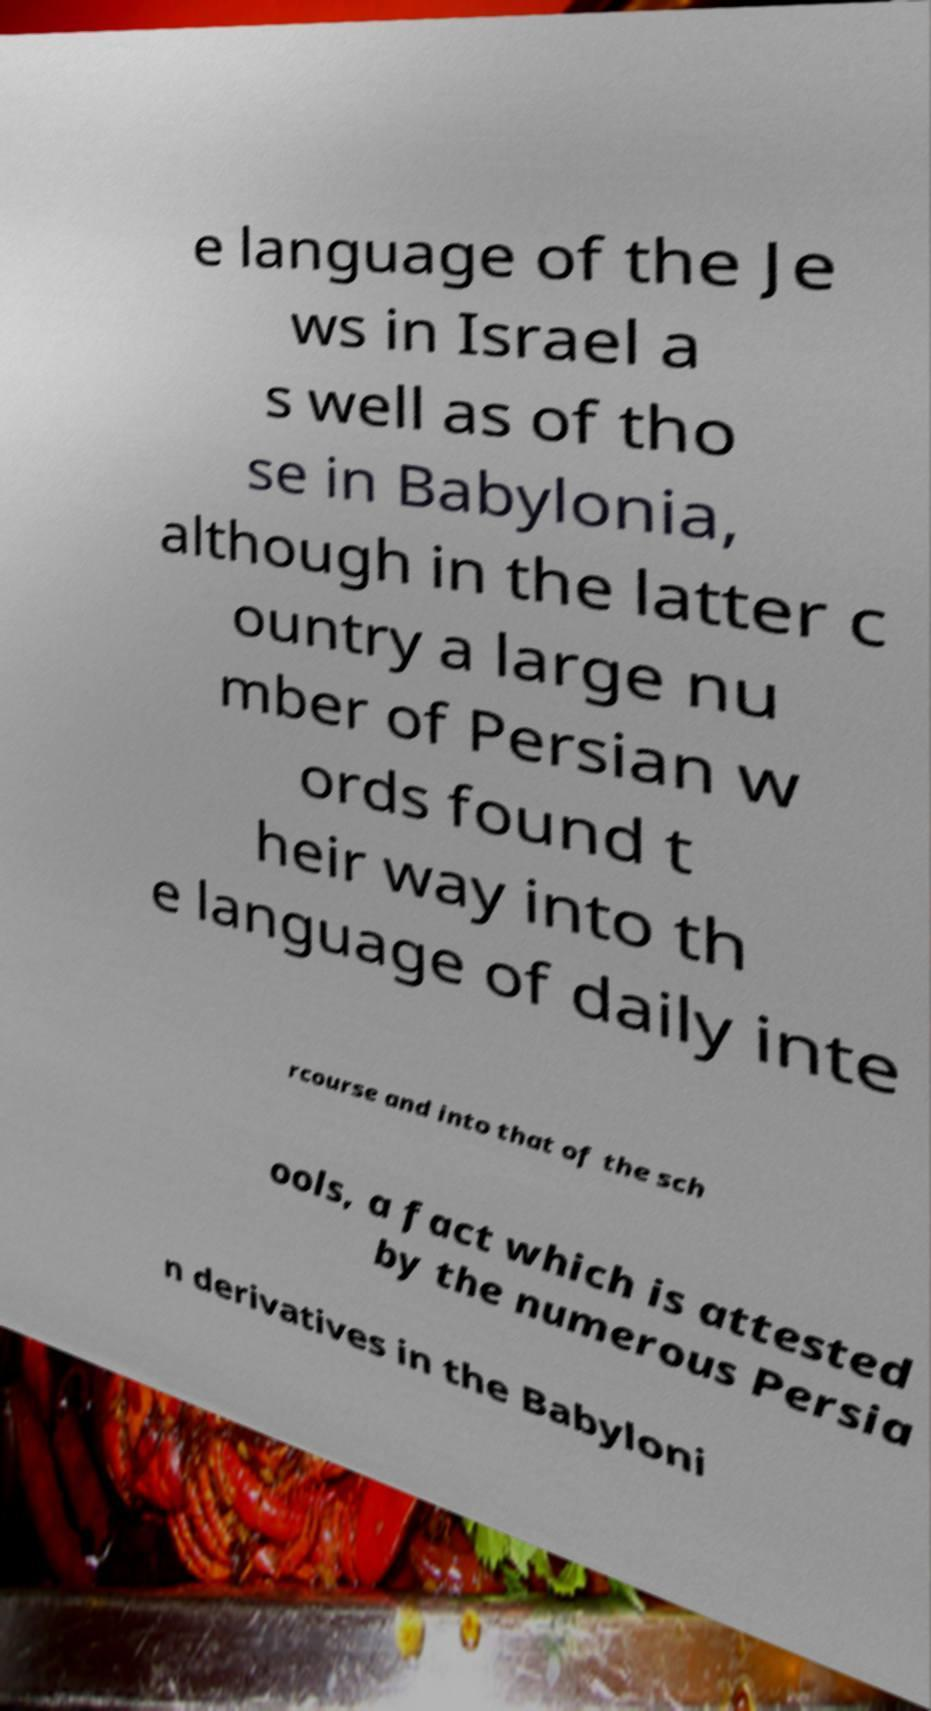What messages or text are displayed in this image? I need them in a readable, typed format. e language of the Je ws in Israel a s well as of tho se in Babylonia, although in the latter c ountry a large nu mber of Persian w ords found t heir way into th e language of daily inte rcourse and into that of the sch ools, a fact which is attested by the numerous Persia n derivatives in the Babyloni 